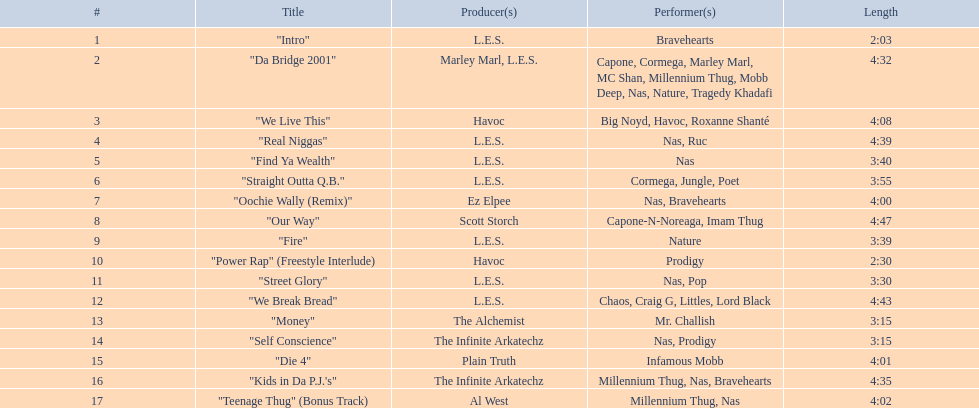What is the first song on the album produced by havoc? "We Live This". 